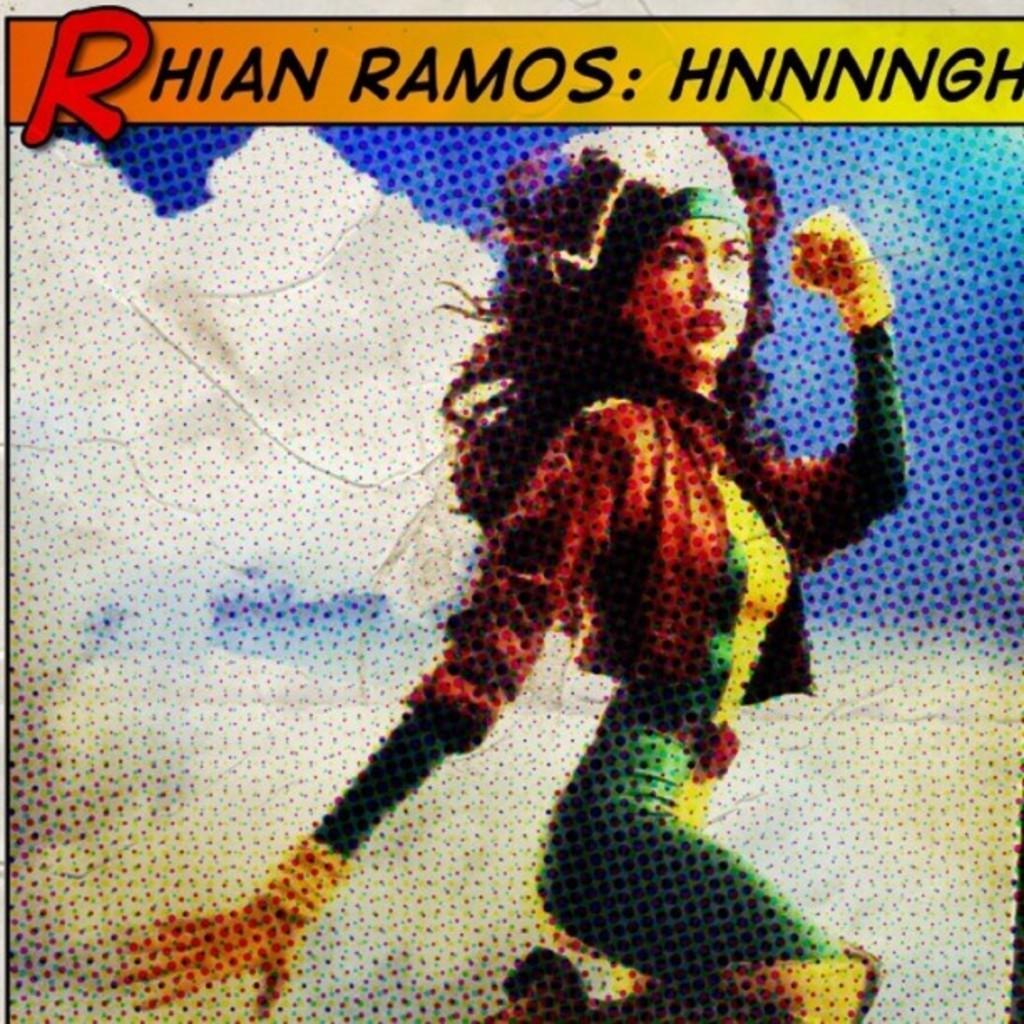What is the main subject of the edited picture? The main subject of the edited picture is a woman. What can be seen at the top of the image? There is a logo at the top of the image. What information is included in the logo? The logo has some text. What is the background of the image? The background of the image is a sky. What can be observed in the sky? Clouds are visible in the sky. How many yams are being held by the woman in the image? There are no yams present in the image. What type of crowd can be seen gathering around the woman in the image? There is no crowd present in the image; it features a woman with a logo and a sky background. 